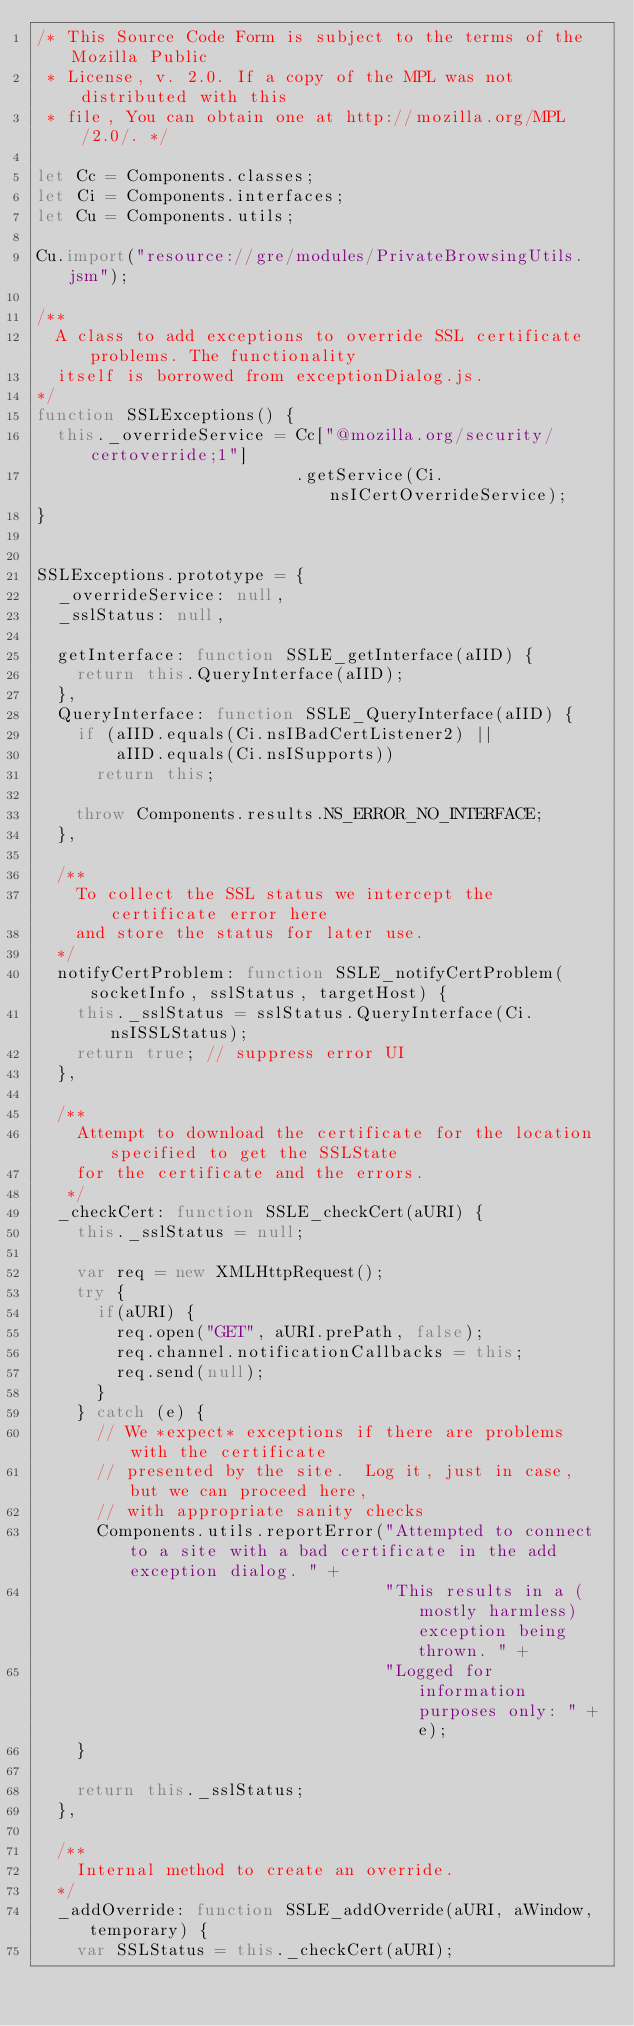<code> <loc_0><loc_0><loc_500><loc_500><_JavaScript_>/* This Source Code Form is subject to the terms of the Mozilla Public
 * License, v. 2.0. If a copy of the MPL was not distributed with this
 * file, You can obtain one at http://mozilla.org/MPL/2.0/. */

let Cc = Components.classes;
let Ci = Components.interfaces;
let Cu = Components.utils;

Cu.import("resource://gre/modules/PrivateBrowsingUtils.jsm");

/**
  A class to add exceptions to override SSL certificate problems. The functionality
  itself is borrowed from exceptionDialog.js.
*/
function SSLExceptions() {
  this._overrideService = Cc["@mozilla.org/security/certoverride;1"]
                          .getService(Ci.nsICertOverrideService);
}


SSLExceptions.prototype = {
  _overrideService: null,
  _sslStatus: null,

  getInterface: function SSLE_getInterface(aIID) {
    return this.QueryInterface(aIID);
  },
  QueryInterface: function SSLE_QueryInterface(aIID) {
    if (aIID.equals(Ci.nsIBadCertListener2) ||
        aIID.equals(Ci.nsISupports))
      return this;

    throw Components.results.NS_ERROR_NO_INTERFACE;
  },

  /**
    To collect the SSL status we intercept the certificate error here
    and store the status for later use.
  */
  notifyCertProblem: function SSLE_notifyCertProblem(socketInfo, sslStatus, targetHost) {
    this._sslStatus = sslStatus.QueryInterface(Ci.nsISSLStatus);
    return true; // suppress error UI
  },

  /**
    Attempt to download the certificate for the location specified to get the SSLState
    for the certificate and the errors.
   */
  _checkCert: function SSLE_checkCert(aURI) {
    this._sslStatus = null;
  
    var req = new XMLHttpRequest();
    try {
      if(aURI) {
        req.open("GET", aURI.prePath, false);
        req.channel.notificationCallbacks = this;
        req.send(null);
      }
    } catch (e) {
      // We *expect* exceptions if there are problems with the certificate
      // presented by the site.  Log it, just in case, but we can proceed here,
      // with appropriate sanity checks
      Components.utils.reportError("Attempted to connect to a site with a bad certificate in the add exception dialog. " +
                                   "This results in a (mostly harmless) exception being thrown. " +
                                   "Logged for information purposes only: " + e);
    }

    return this._sslStatus;
  },

  /**
    Internal method to create an override.
  */
  _addOverride: function SSLE_addOverride(aURI, aWindow, temporary) {
    var SSLStatus = this._checkCert(aURI);</code> 